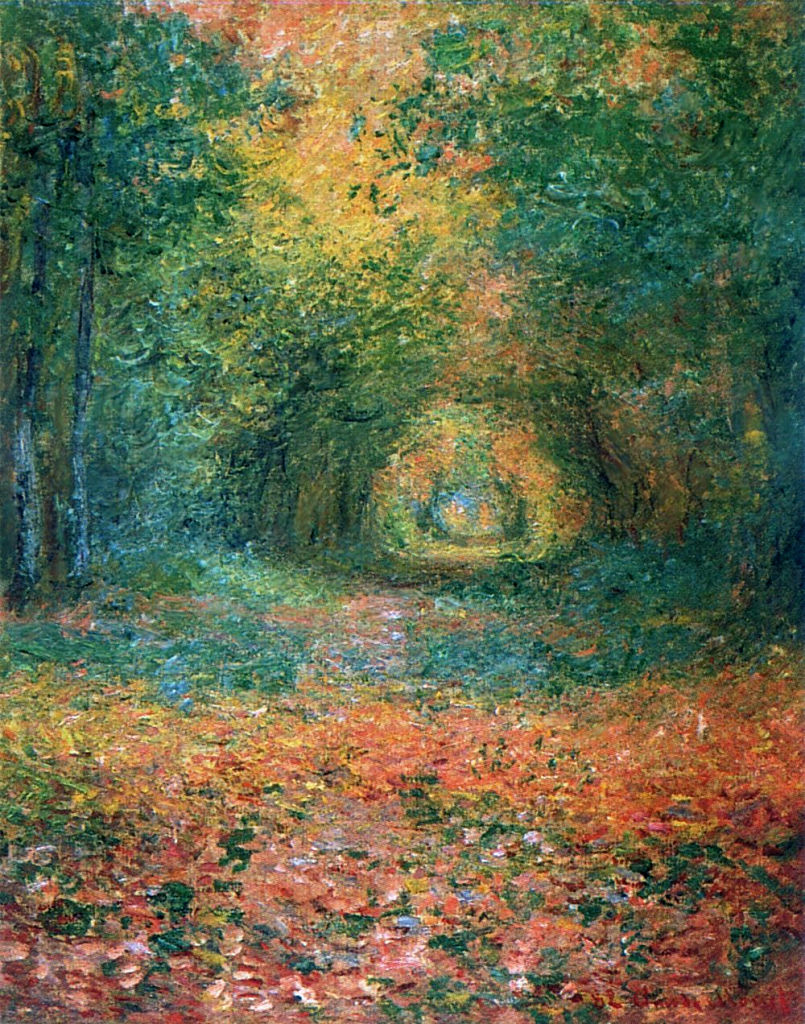Can you describe the significance of the color choices in this painting? Certainly! The predominant use of greens and oranges not only reflects the natural colors one might find in a forest during early autumn, but also serves to evoke a warm, inviting atmosphere. The interspersed blues and yellows hint at the presence of sky and sunlight, subtly influencing the viewer's emotional reception of the scene to feel more lively and vibrant. The choice of colors is crucial in impressionism for conveying mood and moment, transcending direct representation to capture the fleeting nature of light and time. 